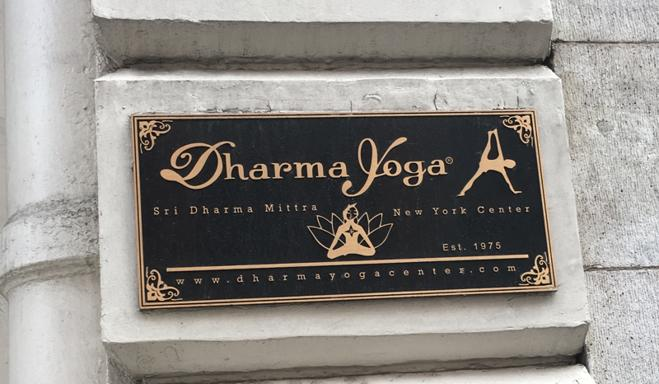How does the choice of colors on the sign contribute to its visual impact? The choice of gold text on a black background in the sign's design is strategic, creating a striking visual contrast that draws the eye and suggests a sense of prestige and seriousness. Gold implies richness and spirituality, aligning well with the yoga center's theme. 